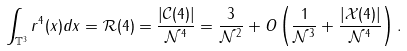Convert formula to latex. <formula><loc_0><loc_0><loc_500><loc_500>\int _ { \mathbb { T } ^ { 3 } } r ^ { 4 } ( x ) d x = \mathcal { R } ( 4 ) = \frac { | \mathcal { C } ( 4 ) | } { \mathcal { N } ^ { 4 } } = \frac { 3 } { \mathcal { N } ^ { 2 } } + O \left ( \frac { 1 } { \mathcal { N } ^ { 3 } } + \frac { | \mathcal { X } ( 4 ) | } { \mathcal { N } ^ { 4 } } \right ) .</formula> 